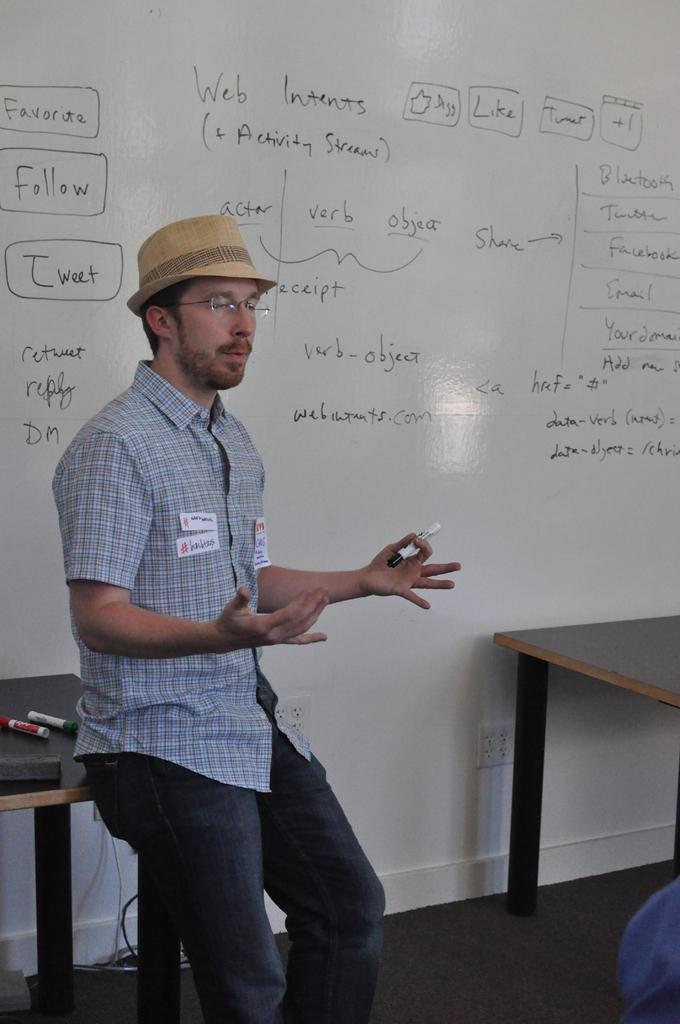<image>
Share a concise interpretation of the image provided. A man in a hat is presenting in front of a large board with Favorite, Follow, and Tweet written in boxes. 